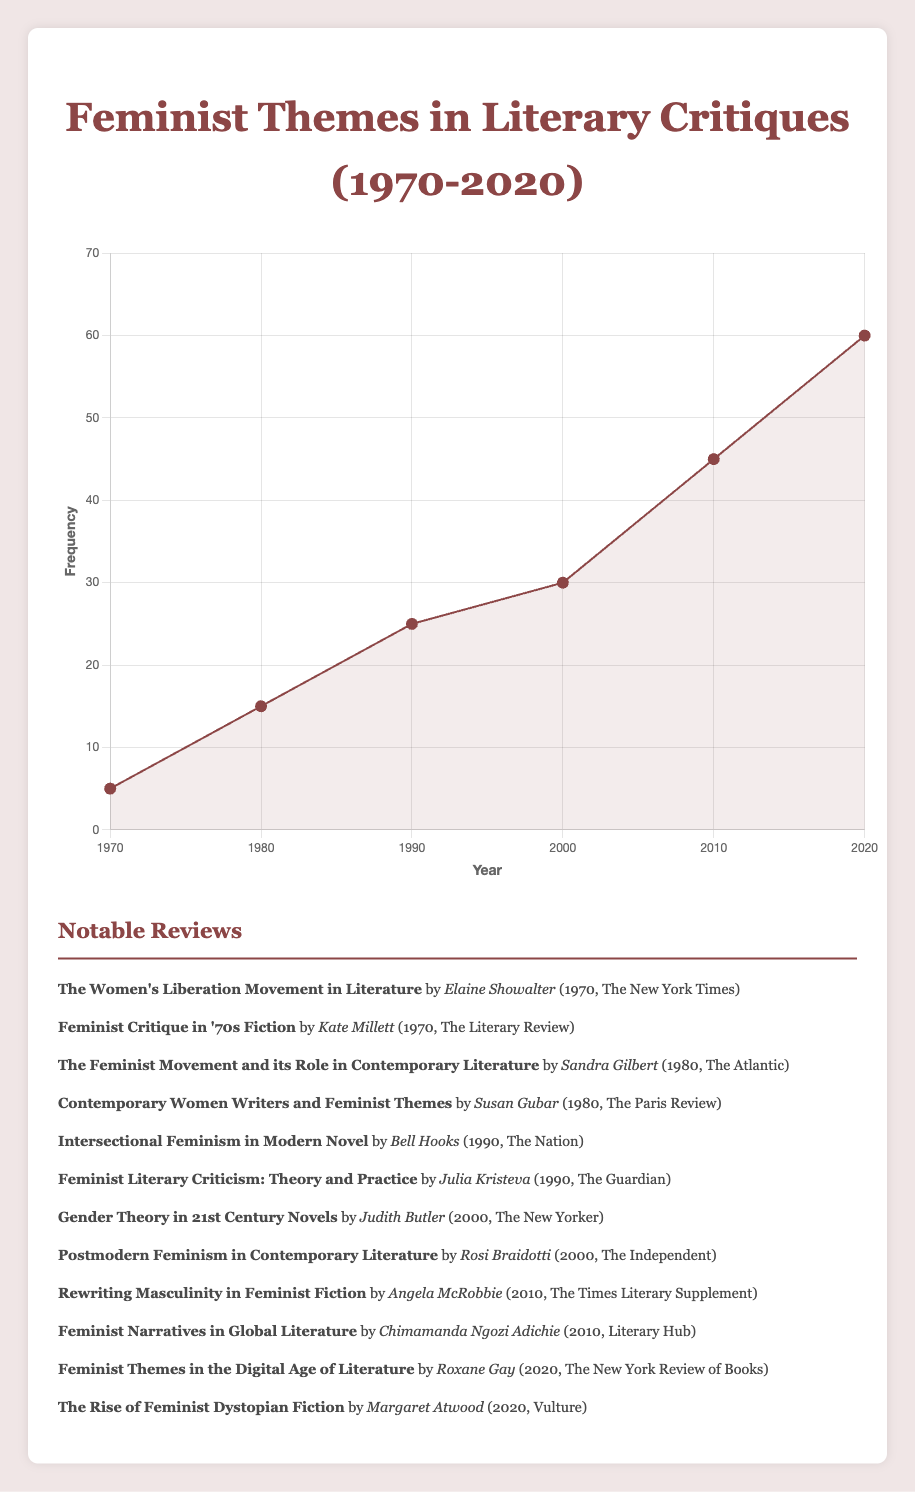What is the frequency of feminist themes in literary critiques in the year 1990? The frequency value for 1990 is shown as a data point on the line chart.
Answer: 25 How does the frequency of feminist themes in 1970 compare to 2020? The frequency in 1970 is 5, and in 2020 it's 60. Since 60 is greater than 5, the frequency in 2020 is higher than in 1970.
Answer: Higher By how much did the frequency of feminist themes increase from 1980 to 2000? The frequency in 1980 is 15 and in 2000 it is 30. The increase is calculated as 30 - 15 = 15.
Answer: 15 What is the average frequency of feminist themes in literary critiques from 1970 to 2020? The frequencies for the years provided are 5, 15, 25, 30, 45, and 60. Summing these gives 180, and there are 6 values, so the average is 180 / 6 = 30.
Answer: 30 In which decade did the frequency see the highest relative increase compared to the previous decade? From 1970 to 1980, the increase is 10 (15 - 5), from 1980 to 1990 it’s 10 (25 - 15), from 1990 to 2000 it’s 5 (30 - 25), from 2000 to 2010 it’s 15 (45 - 30), and from 2010 to 2020 it’s 15 (60 - 45). The highest relative increase happened from 2000 to 2010.
Answer: 2000 to 2010 What notable trends can you observe in the changes in frequency of feminist themes from 1970 to 2020? The frequency shows a consistent rise over the decades. There are notable jumps every decade, with significant increases especially in the latter decades (2000s and 2010s).
Answer: Consistent rise Which year had the most significant growth in frequency compared to the previous decade? Comparing the increases: from 1970 to 1980 is 10, from 1980 to 1990 is 10, from 1990 to 2000 is 5, from 2000 to 2010 is 15, and 2010 to 2020 is 15. The most significant growth is from 2000 to 2010 and from 2010 to 2020.
Answer: 2000 to 2010 and 2010 to 2020 